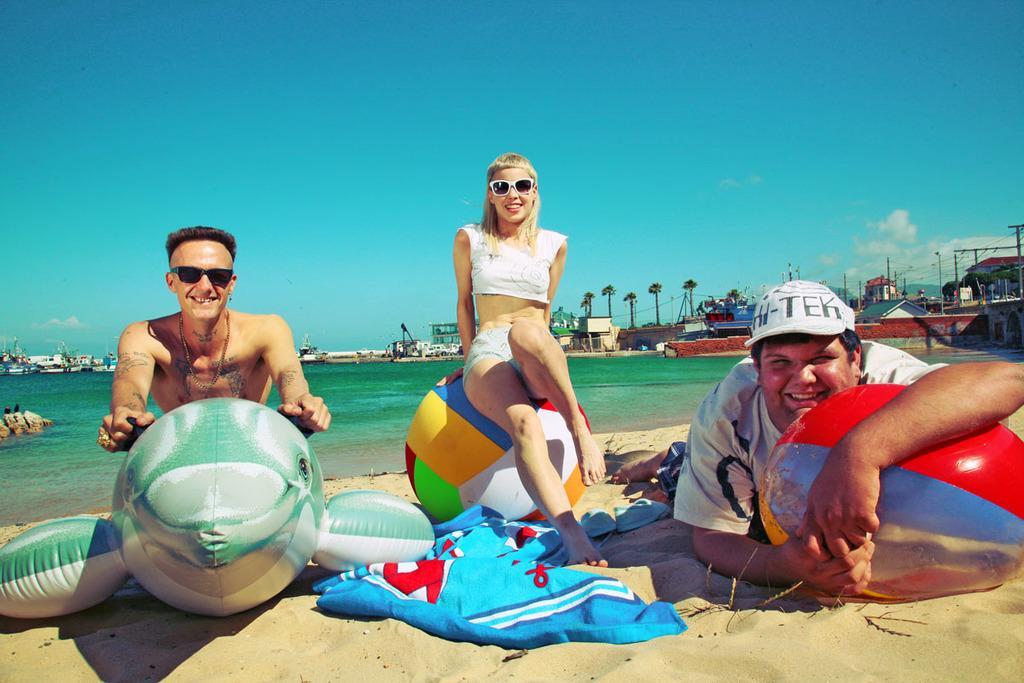In one or two sentences, can you explain what this image depicts? In this picture there are three person on the beach. Beside them I can see the balls, clothes and toys. In the back I can see the river. In the background I can see the trees, poles, wires, shed, building, boards and other objects. At the top I can see the sky and clouds. 